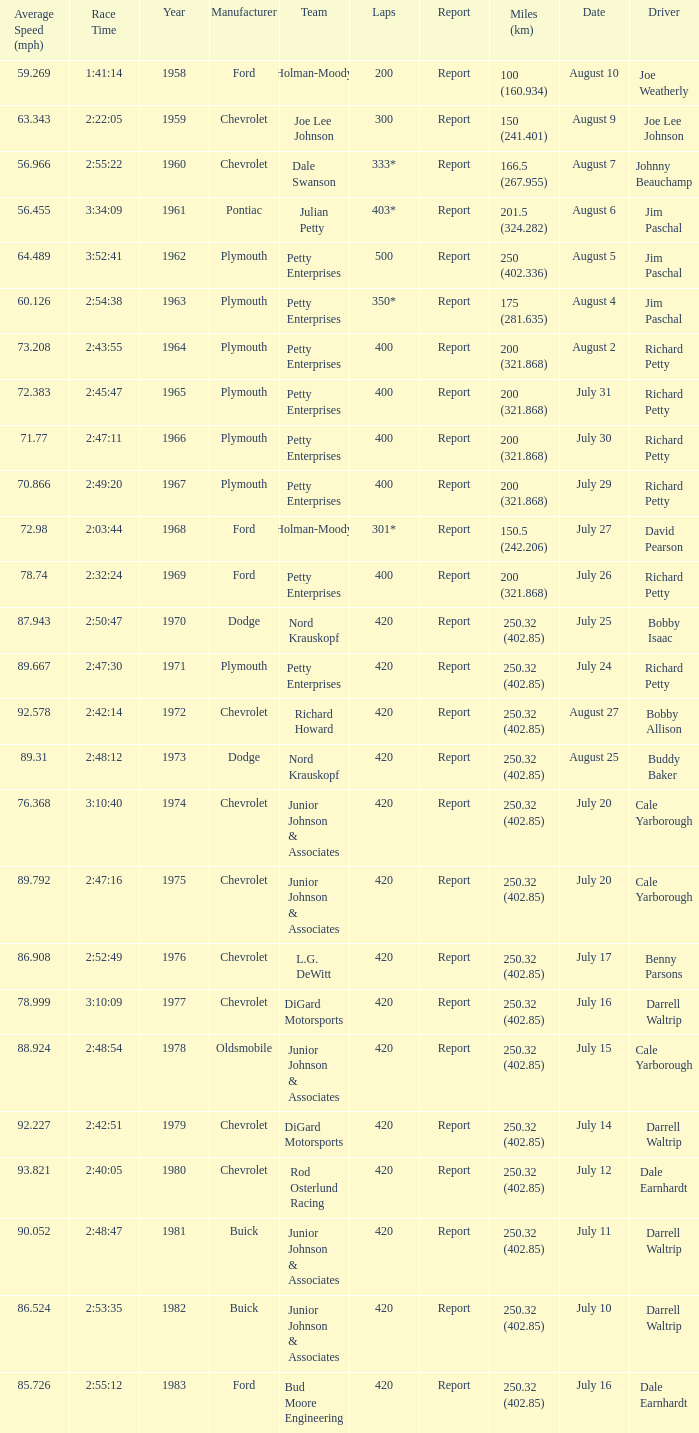How many races did Cale Yarborough win at an average speed of 88.924 mph? 1.0. 